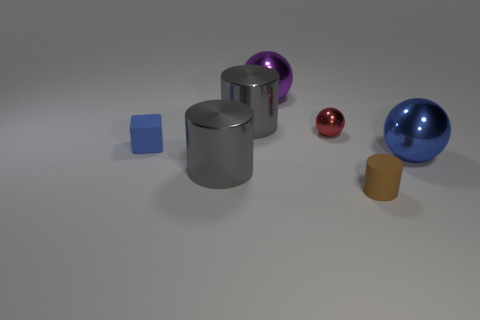There is a cube; is it the same color as the rubber object that is to the right of the purple shiny thing?
Give a very brief answer. No. Is the number of brown rubber cylinders that are behind the large purple metal sphere less than the number of small cylinders that are behind the brown rubber cylinder?
Provide a short and direct response. No. There is a metallic thing that is both on the left side of the red metal sphere and in front of the red sphere; what color is it?
Your answer should be very brief. Gray. Does the red ball have the same size as the matte object in front of the blue rubber thing?
Your answer should be very brief. Yes. What shape is the small matte object left of the tiny cylinder?
Offer a very short reply. Cube. Is there anything else that is the same material as the large blue thing?
Offer a very short reply. Yes. Are there more blue objects that are on the right side of the red metal thing than brown rubber objects?
Provide a succinct answer. No. There is a large metallic object right of the tiny red object that is right of the purple sphere; what number of large blue objects are behind it?
Offer a very short reply. 0. Do the rubber object that is right of the purple ball and the ball that is in front of the tiny blue rubber cube have the same size?
Your answer should be compact. No. There is a big cylinder behind the ball that is right of the tiny brown cylinder; what is it made of?
Offer a terse response. Metal. 